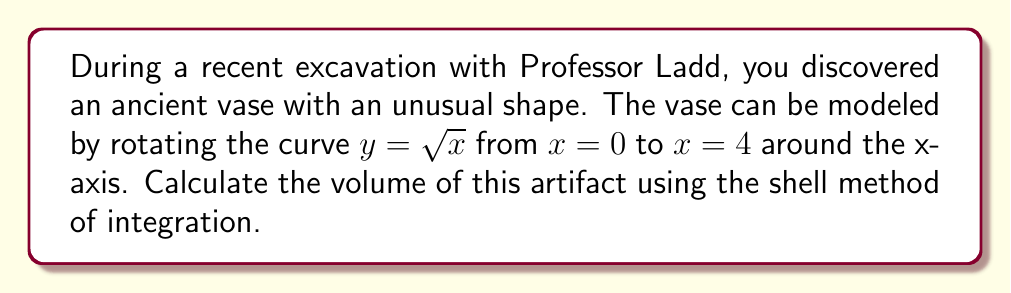Can you solve this math problem? To solve this problem, we'll use the shell method of integration. The steps are as follows:

1) The shell method formula for volume is:

   $$V = 2\pi \int_a^b y \cdot x \, dx$$

   where $y$ is the radius of each shell and $x$ is the height.

2) In this case, $y = \sqrt{x}$, $a = 0$, and $b = 4$. Substituting these into our formula:

   $$V = 2\pi \int_0^4 \sqrt{x} \cdot x \, dx$$

3) Simplify the integrand:

   $$V = 2\pi \int_0^4 x^{3/2} \, dx$$

4) Integrate:

   $$V = 2\pi \left[ \frac{2}{5}x^{5/2} \right]_0^4$$

5) Evaluate the definite integral:

   $$V = 2\pi \left( \frac{2}{5}(4)^{5/2} - \frac{2}{5}(0)^{5/2} \right)$$

6) Simplify:

   $$V = 2\pi \cdot \frac{2}{5} \cdot 4^{5/2}$$
   $$V = \frac{4\pi}{5} \cdot 32$$
   $$V = \frac{128\pi}{5} \approx 80.42$$

Therefore, the volume of the vase is $\frac{128\pi}{5}$ cubic units.
Answer: $\frac{128\pi}{5}$ cubic units 